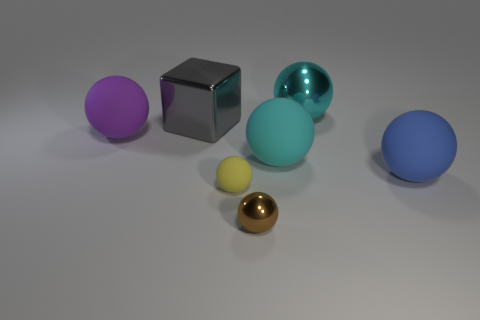There is a matte thing in front of the rubber sphere on the right side of the large cyan thing that is behind the large gray metallic thing; what is its color?
Your answer should be compact. Yellow. What shape is the gray object that is the same size as the purple rubber sphere?
Offer a very short reply. Cube. Is the number of large brown objects greater than the number of large blue matte balls?
Ensure brevity in your answer.  No. Are there any shiny cubes left of the large gray shiny thing that is behind the tiny yellow thing?
Your answer should be very brief. No. There is another small object that is the same shape as the tiny yellow thing; what color is it?
Provide a short and direct response. Brown. Is there any other thing that is the same shape as the tiny matte thing?
Provide a short and direct response. Yes. The big object that is made of the same material as the big block is what color?
Ensure brevity in your answer.  Cyan. Are there any blue things on the right side of the big matte thing that is on the right side of the metallic ball that is behind the large cyan matte thing?
Your response must be concise. No. Are there fewer big spheres to the left of the gray object than brown spheres behind the big purple matte ball?
Offer a terse response. No. How many big balls have the same material as the gray object?
Your answer should be compact. 1. 